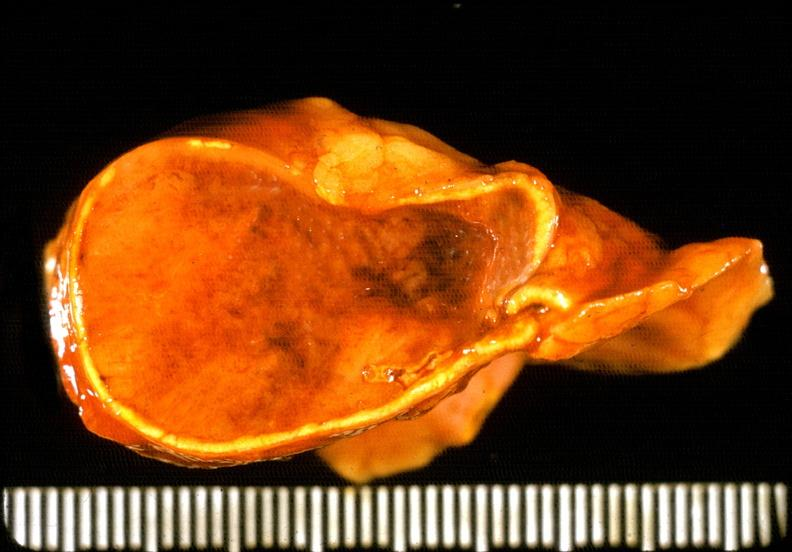what is present?
Answer the question using a single word or phrase. Endocrine 